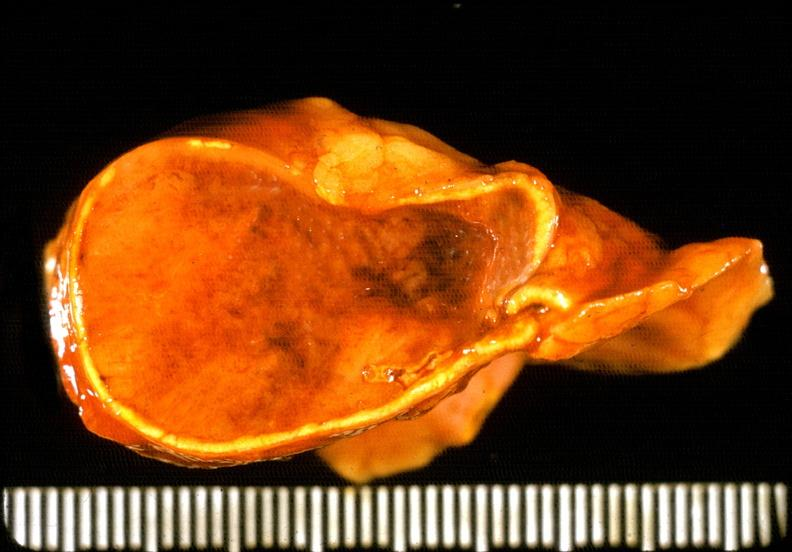what is present?
Answer the question using a single word or phrase. Endocrine 